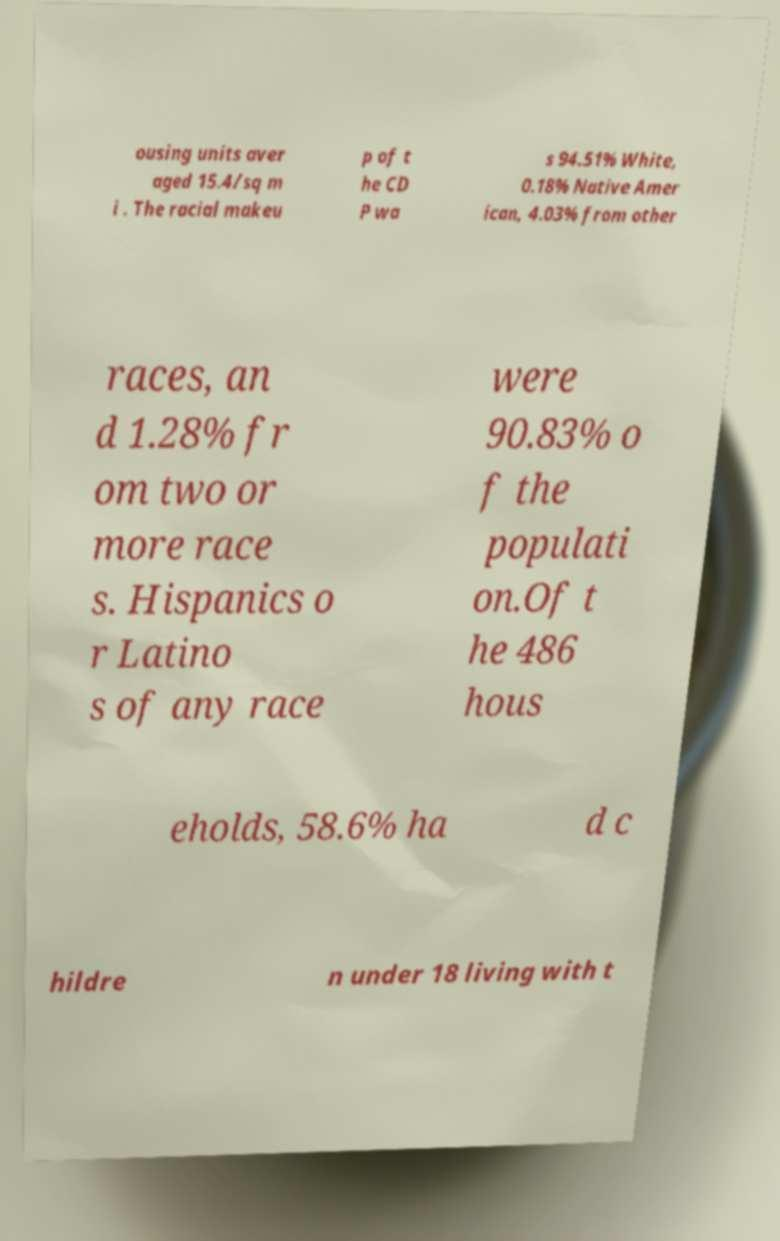Can you read and provide the text displayed in the image?This photo seems to have some interesting text. Can you extract and type it out for me? ousing units aver aged 15.4/sq m i . The racial makeu p of t he CD P wa s 94.51% White, 0.18% Native Amer ican, 4.03% from other races, an d 1.28% fr om two or more race s. Hispanics o r Latino s of any race were 90.83% o f the populati on.Of t he 486 hous eholds, 58.6% ha d c hildre n under 18 living with t 